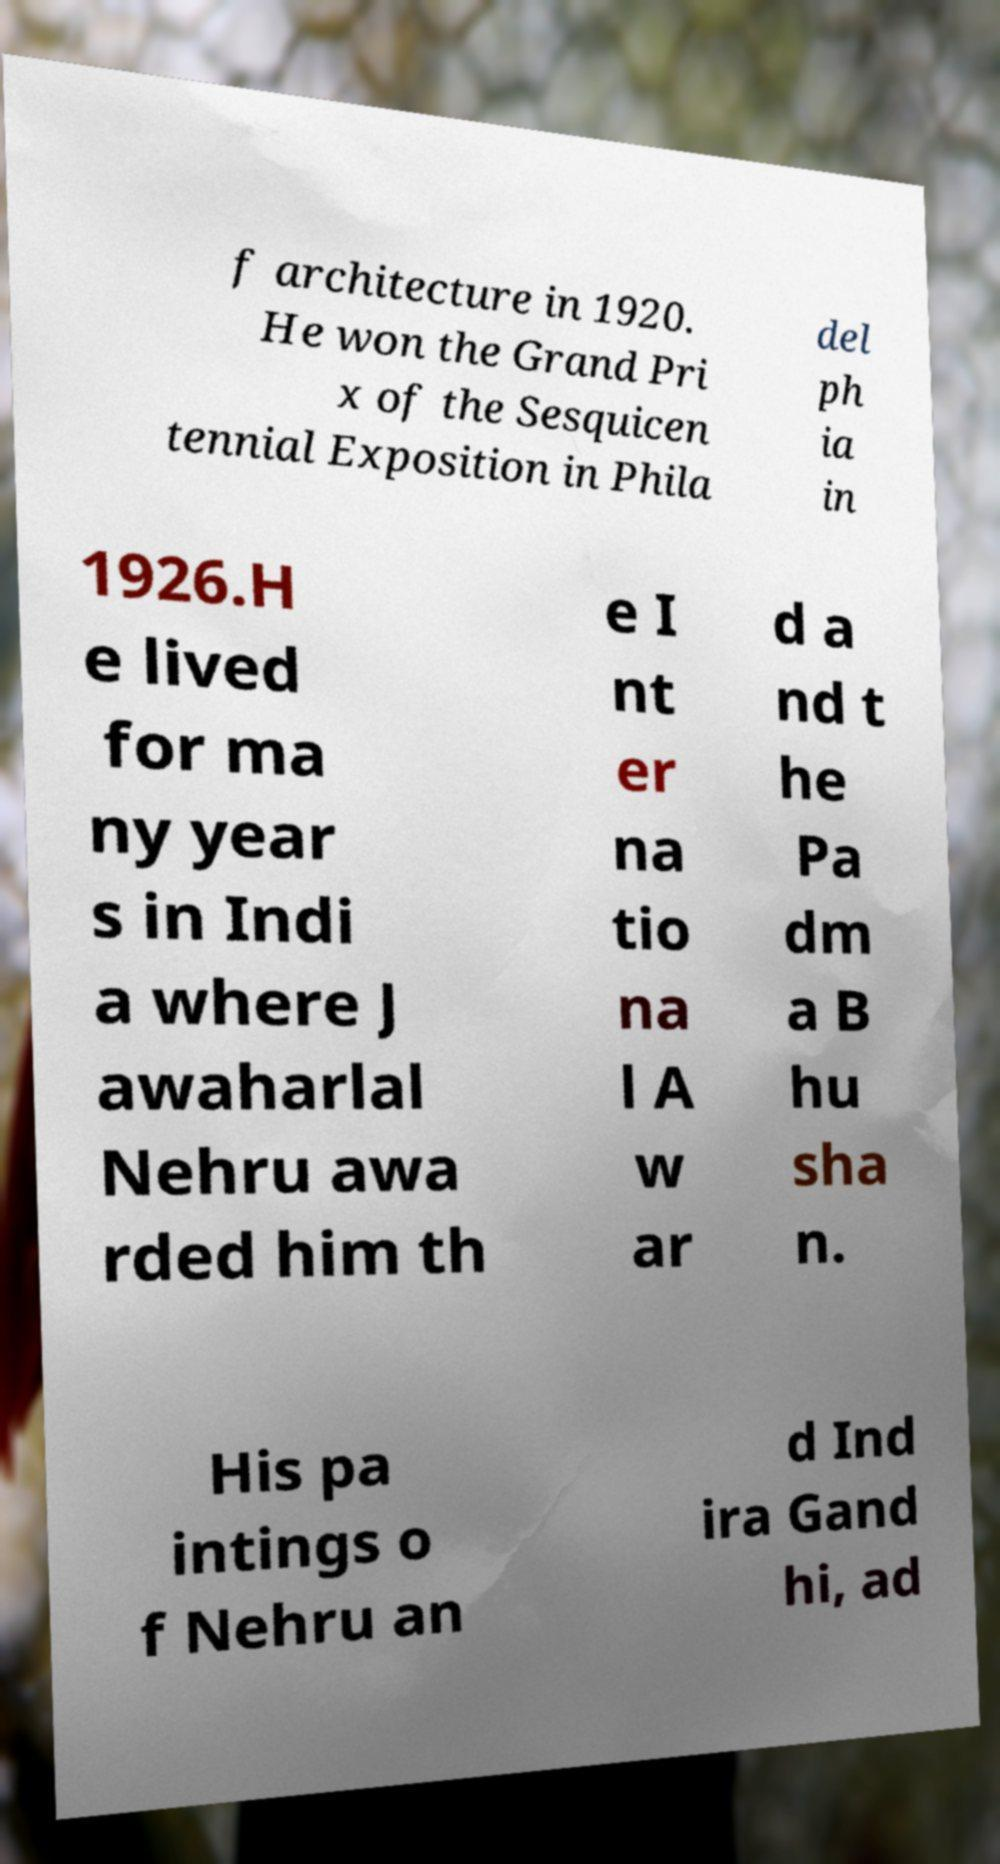Please read and relay the text visible in this image. What does it say? f architecture in 1920. He won the Grand Pri x of the Sesquicen tennial Exposition in Phila del ph ia in 1926.H e lived for ma ny year s in Indi a where J awaharlal Nehru awa rded him th e I nt er na tio na l A w ar d a nd t he Pa dm a B hu sha n. His pa intings o f Nehru an d Ind ira Gand hi, ad 